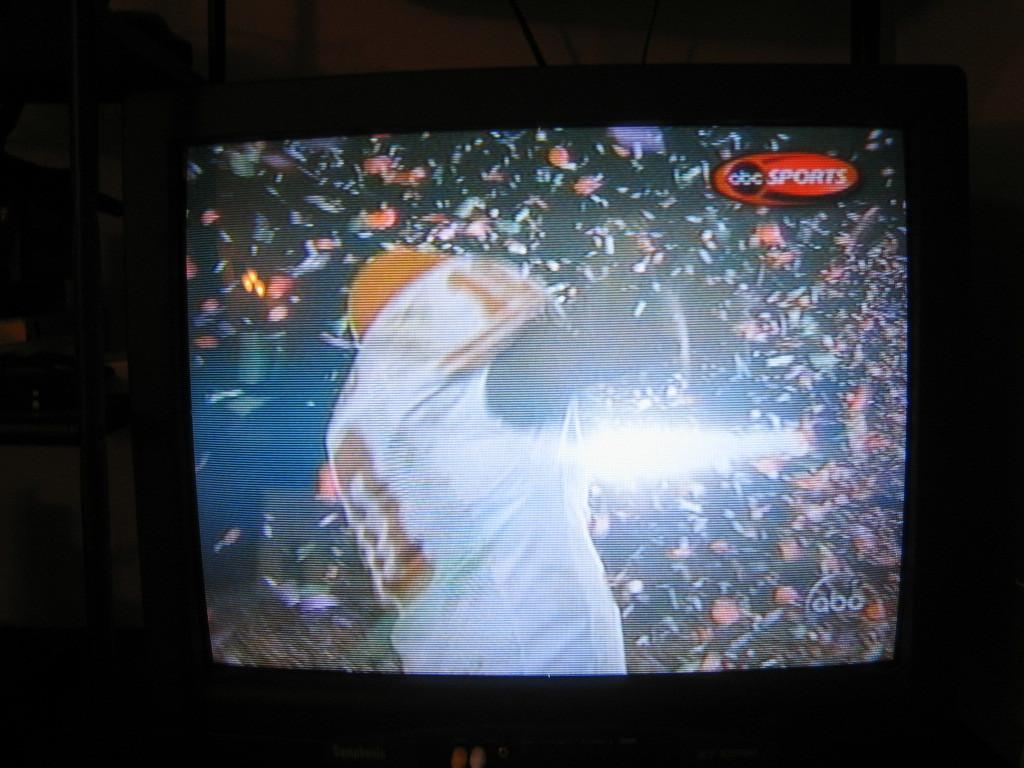What electronic device can be seen in the image? There is a television in the image. What is the primary feature of the television? The television has a screen. What is displayed on the television screen? A person is visible on the television screen. What objects can be seen on a nearby rack? There is a rack with objects beside the television. Can you tell me how many hens are sitting on the television screen? There are no hens present on the television screen; it displays a person. What is the purpose of the burst of light in the image? There is no burst of light present in the image. 